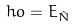Convert formula to latex. <formula><loc_0><loc_0><loc_500><loc_500>\ h o = E _ { \hat { N } }</formula> 